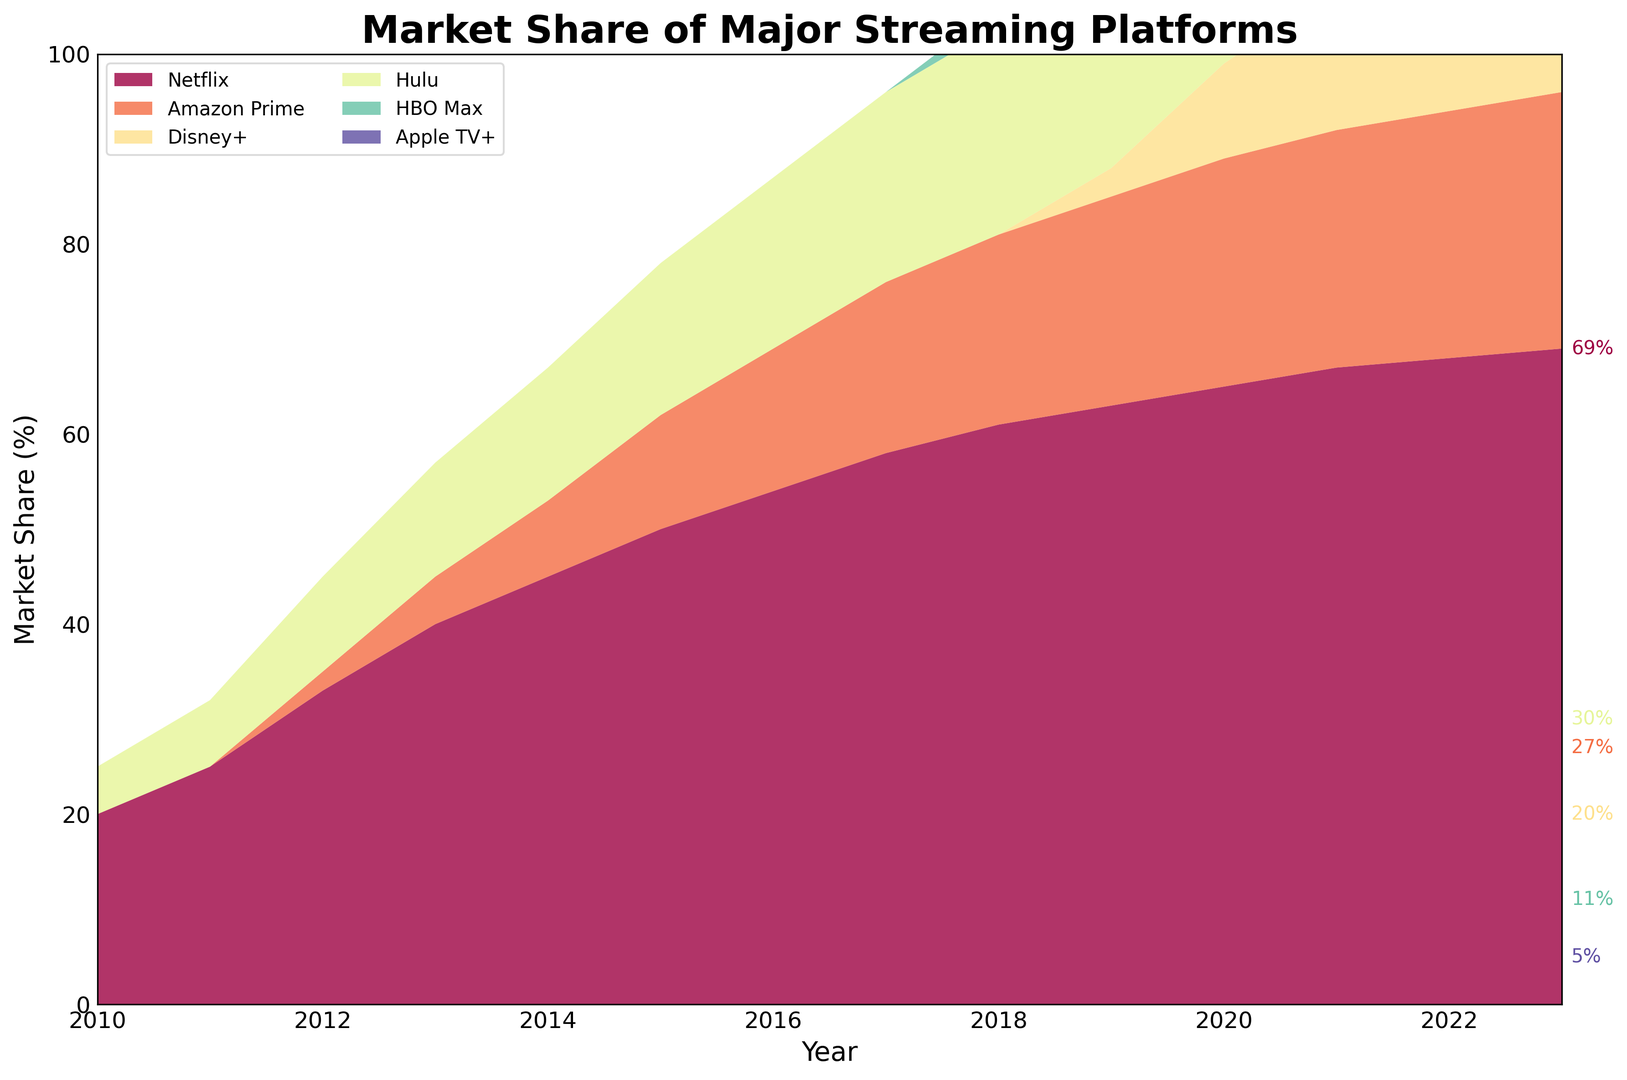What has been the trend of Netflix's market share from 2010 to 2023? To determine Netflix's trend, examine the area corresponding to Netflix from 2010 to 2023. The area grows steadily from 20% in 2010 to 69% in 2023. This increase shows a clear upward trend over the years.
Answer: Upward trend In which year did Disney+ first appear in the market share? Look for the first appearance of the Disney+ color area on the chart. The first visible year is 2019, with a market share of 3%.
Answer: 2019 Which two platforms have shown consistent growth without any decline from 2010 to 2023? Scan the chart for platforms where their area always increases. Both Netflix and Amazon Prime show consistent growth every year without any declines.
Answer: Netflix and Amazon Prime As of 2023, which platform has the lowest market share? Check the labels and values for all platforms in 2023. Apple TV+ has the lowest, with a market share of 5%.
Answer: Apple TV+ How does Hulu's market share in 2023 compare to 2010? Identify Hulu's market share in 2010 and 2023 from the chart. In 2010, it's 5%, and in 2023, it's 30%. Thus, there's an increase of 25%.
Answer: Increased by 25% What is the combined market share of Netflix and Disney+ in 2023? Netflix has 69%, and Disney+ has 20% in 2023. Add these values: 69% + 20% = 89%. So, the combined market share is 89%.
Answer: 89% Which platform has the most growth between any two consecutive years, and in which year? Compare the year-on-year differences for each platform. Disney+ has the most growth of 7%, from 3% in 2019 to 10% in 2020.
Answer: Disney+ between 2019-2020 Which platform shows the most significant increase in 2020 compared to 2019? Identify and compare the differences for all platforms between 2019 and 2020. Disney+ shows the largest increase, from 3% to 10%, which is a 7% rise.
Answer: Disney+ How does the market share of HBO Max in 2020 compare to Apple TV+ in the same year? Check the values for both in 2020. HBO Max has 6%, and Apple TV+ has 2%. Thus, HBO Max's share is higher.
Answer: HBO Max is higher What is the total market share represented by all platforms in 2015? Sum the shares of all platforms in 2015: Netflix (50%) + Amazon Prime (12%) + Hulu (16%) = 78%.
Answer: 78% 